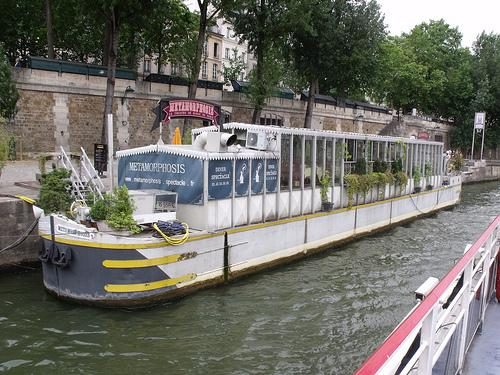Question: what color are the trees?
Choices:
A. Brown.
B. Green.
C. Yellow.
D. Red.
Answer with the letter. Answer: B Question: why was the picture taken?
Choices:
A. For a magazine.
B. For posterity.
C. To test the camera.
D. For a billboard.
Answer with the letter. Answer: A Question: when was the picture taken?
Choices:
A. In the afternoon.
B. Early morning.
C. Night time.
D. Dusk.
Answer with the letter. Answer: A 